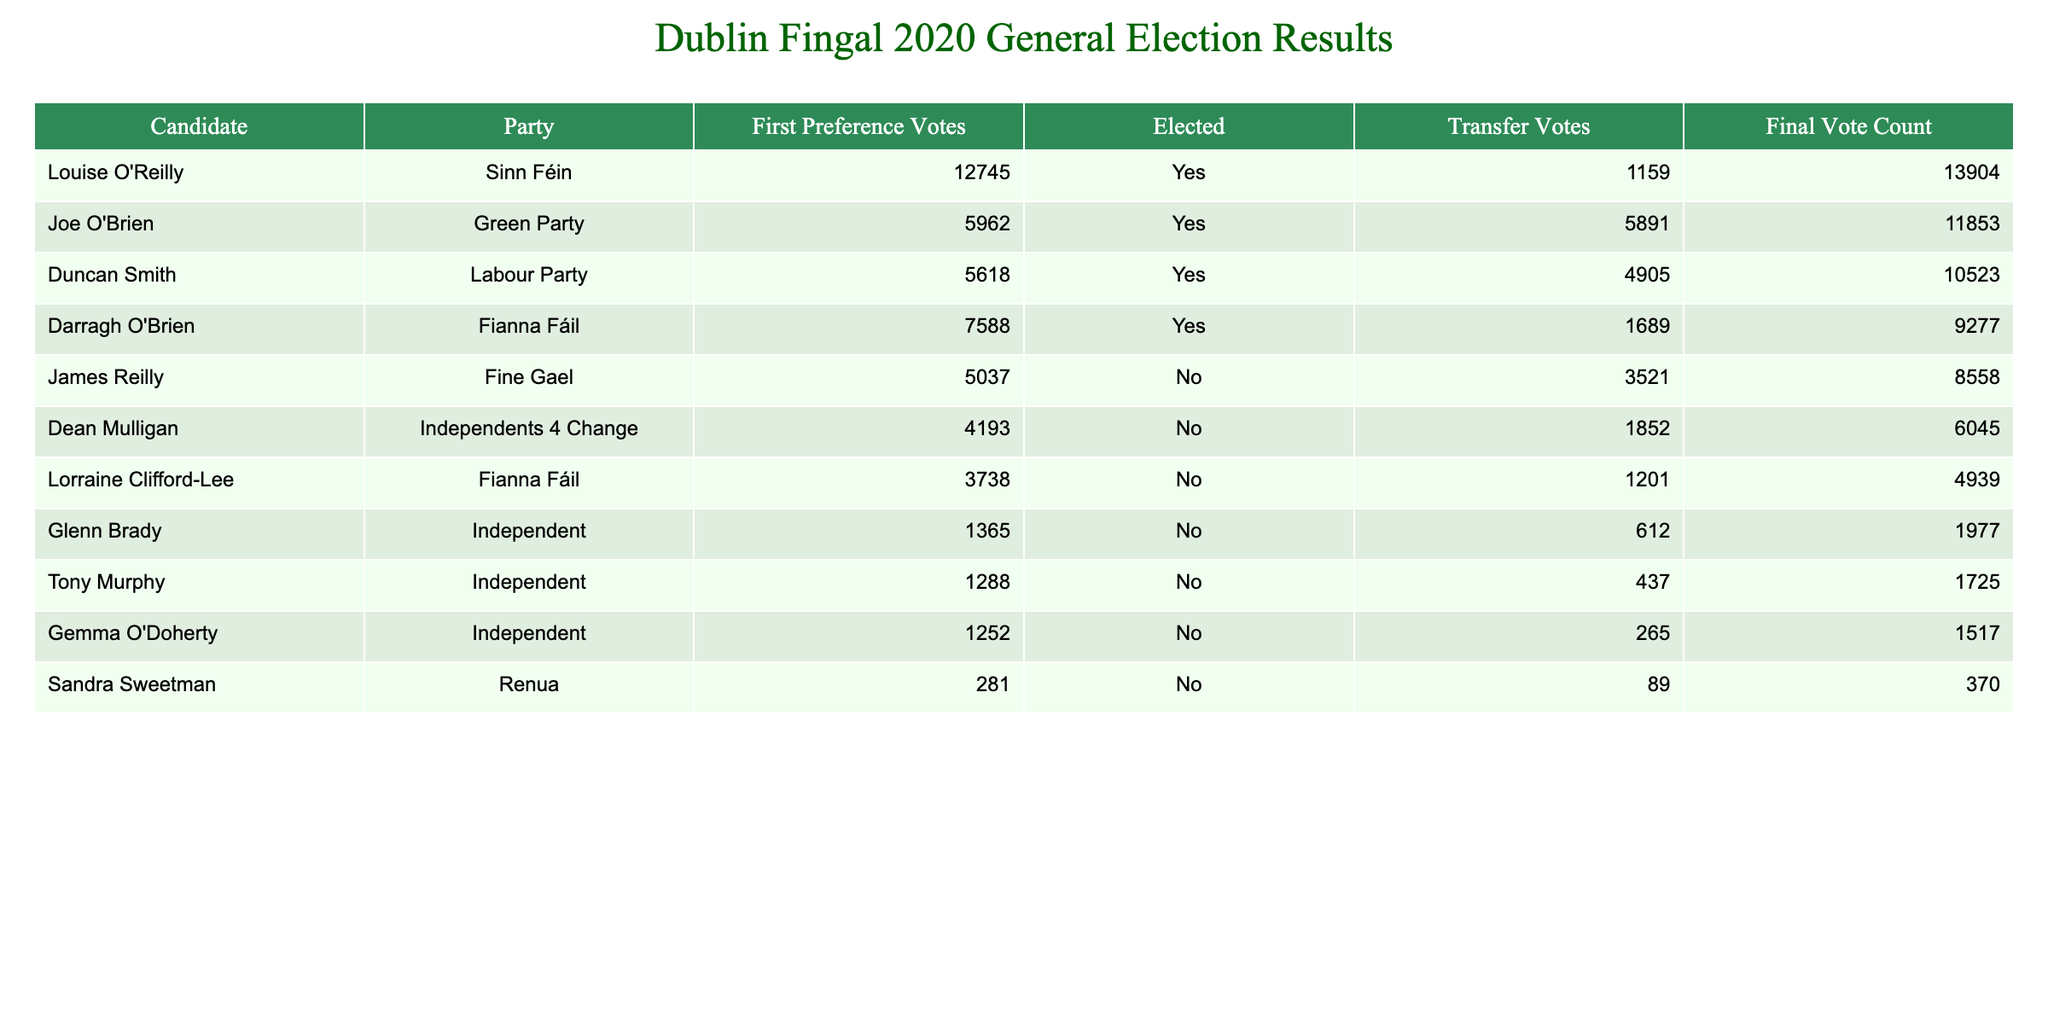What is the total number of first preference votes for all elected candidates? To find the total first preference votes for elected candidates, we first identify the candidates who were elected, which are Louise O'Reilly, Joe O'Brien, Duncan Smith, and Darragh O'Brien. Their first preference votes are 12745, 5962, 5618, and 7588 respectively. We then sum these values: 12745 + 5962 + 5618 + 7588 = 32713.
Answer: 32713 Which party had the highest total final vote count among the candidates? We need to check the final vote counts for all candidates. The final vote counts are as follows: Sinn Féin (13904), Green Party (11853), Labour Party (10523), Fianna Fáil (9277), Fine Gael (8558), Independents 4 Change (6045), and Independents (1977). The highest count is from Sinn Féin with 13904.
Answer: Sinn Féin Did Joe O'Brien receive more transfer votes than Darragh O'Brien? Checking the transfer votes, Joe O'Brien received 5891 transfer votes, while Darragh O'Brien received 1689 transfer votes. Since 5891 is greater than 1689, the answer is yes.
Answer: Yes What is the average final vote count of all candidates? First, we calculate the final vote counts: 13904, 11853, 10523, 9277, 8558, 6045, 1977, 1725, 1517, and 370. The total of these is 50003. There are 10 candidates, so we divide the total by 10 to get the average: 50003 / 10 = 5000.3.
Answer: 5000.3 Which candidate received the lowest number of first preference votes, and how many did they receive? We look through the first preference votes: 12745, 5962, 5618, 7588, 5037, 4193, 3738, 1365, 1288, 1252, and 281. The lowest number is 281, which corresponds to Sandra Sweetman.
Answer: Sandra Sweetman, 281 